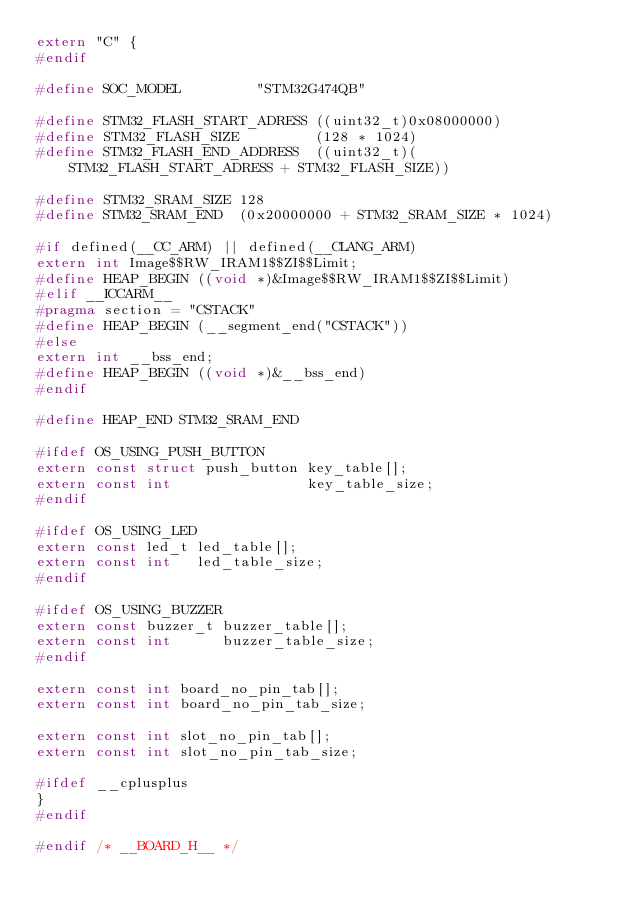Convert code to text. <code><loc_0><loc_0><loc_500><loc_500><_C_>extern "C" {
#endif

#define SOC_MODEL         "STM32G474QB" 

#define STM32_FLASH_START_ADRESS ((uint32_t)0x08000000)
#define STM32_FLASH_SIZE         (128 * 1024)
#define STM32_FLASH_END_ADDRESS  ((uint32_t)(STM32_FLASH_START_ADRESS + STM32_FLASH_SIZE))

#define STM32_SRAM_SIZE 128
#define STM32_SRAM_END  (0x20000000 + STM32_SRAM_SIZE * 1024)

#if defined(__CC_ARM) || defined(__CLANG_ARM)
extern int Image$$RW_IRAM1$$ZI$$Limit;
#define HEAP_BEGIN ((void *)&Image$$RW_IRAM1$$ZI$$Limit)
#elif __ICCARM__
#pragma section = "CSTACK"
#define HEAP_BEGIN (__segment_end("CSTACK"))
#else
extern int __bss_end;
#define HEAP_BEGIN ((void *)&__bss_end)
#endif

#define HEAP_END STM32_SRAM_END

#ifdef OS_USING_PUSH_BUTTON
extern const struct push_button key_table[];
extern const int                key_table_size;
#endif

#ifdef OS_USING_LED
extern const led_t led_table[];
extern const int   led_table_size;
#endif

#ifdef OS_USING_BUZZER
extern const buzzer_t buzzer_table[];
extern const int      buzzer_table_size;
#endif

extern const int board_no_pin_tab[];
extern const int board_no_pin_tab_size;

extern const int slot_no_pin_tab[];
extern const int slot_no_pin_tab_size;

#ifdef __cplusplus
}
#endif

#endif /* __BOARD_H__ */
</code> 